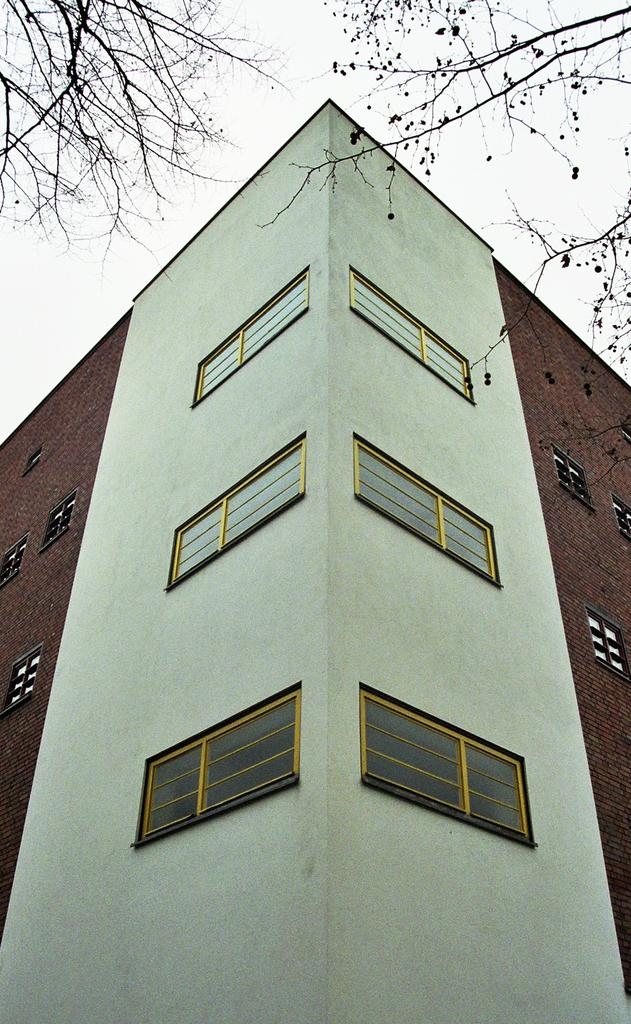What is the main subject in the foreground of the image? There is a building in the foreground of the image. Are there any natural elements visible in the image? Yes, there are branches of trees visible in the top left and top right corners of the image. What type of boot is hanging from the wire in the image? There is no wire or boot present in the image. What policy has the governor implemented in the image? There is no governor or policy mentioned in the image. 